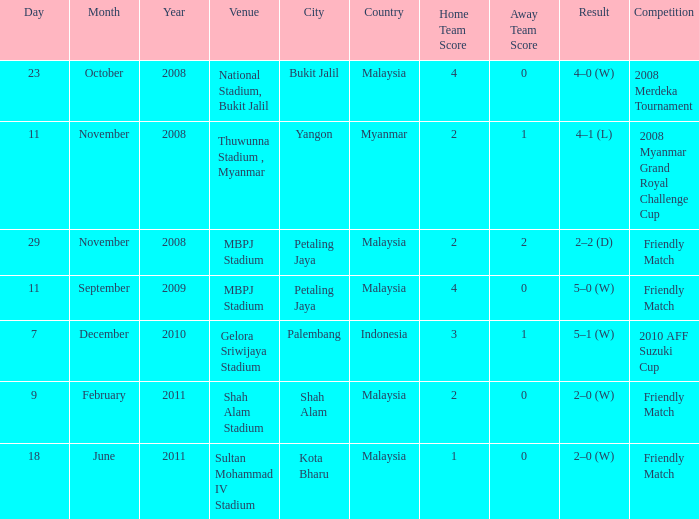At which site was the contest conducted that had a 2-2 (d) final score? MBPJ Stadium. 